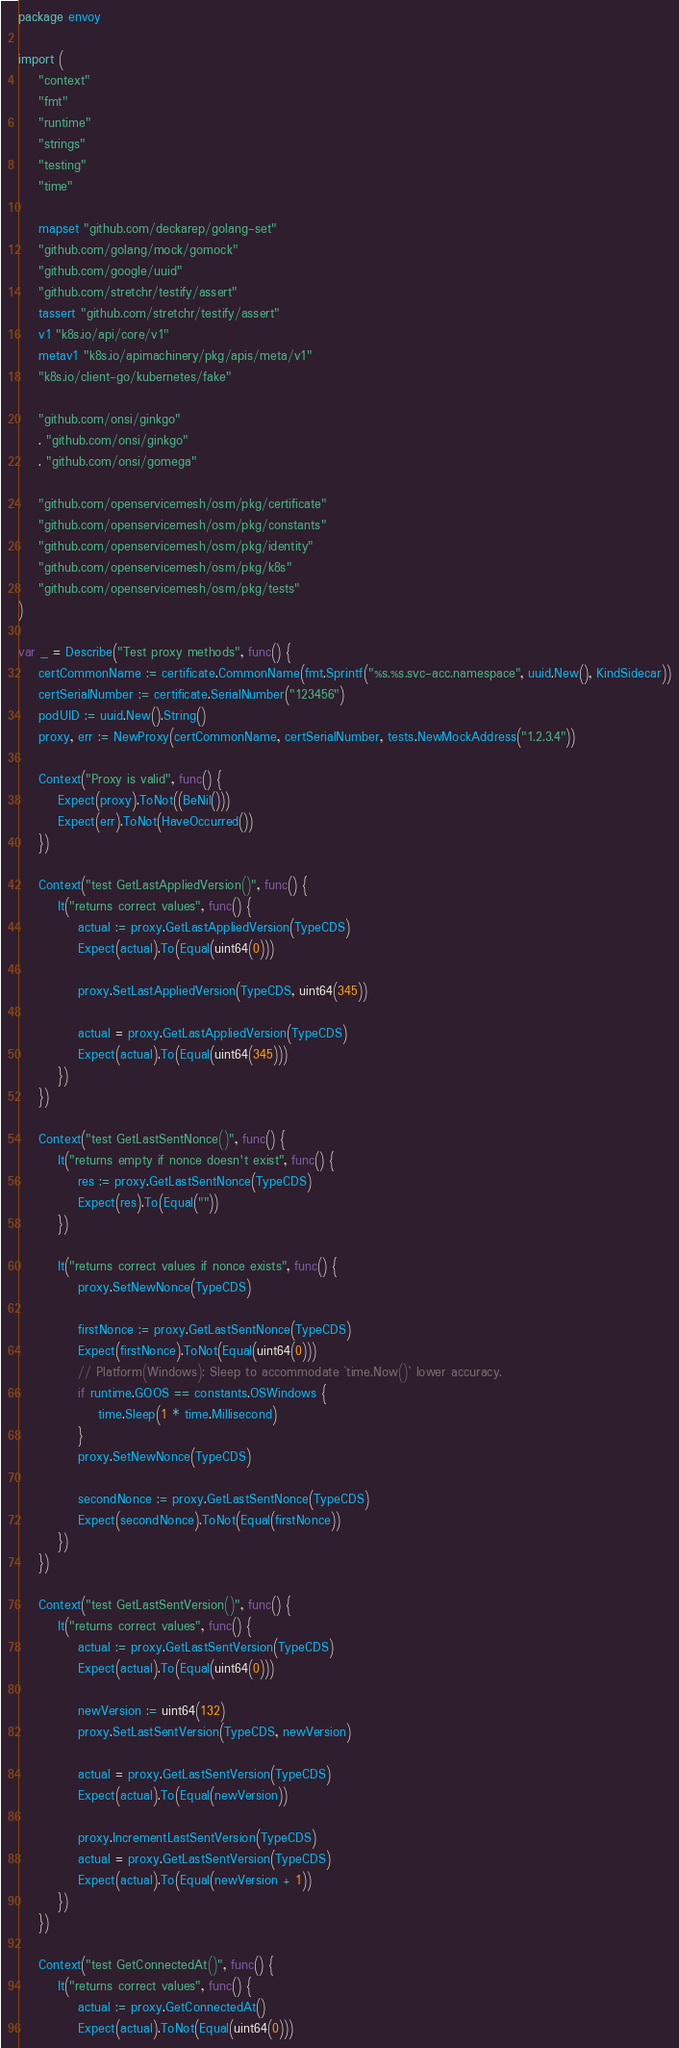Convert code to text. <code><loc_0><loc_0><loc_500><loc_500><_Go_>package envoy

import (
	"context"
	"fmt"
	"runtime"
	"strings"
	"testing"
	"time"

	mapset "github.com/deckarep/golang-set"
	"github.com/golang/mock/gomock"
	"github.com/google/uuid"
	"github.com/stretchr/testify/assert"
	tassert "github.com/stretchr/testify/assert"
	v1 "k8s.io/api/core/v1"
	metav1 "k8s.io/apimachinery/pkg/apis/meta/v1"
	"k8s.io/client-go/kubernetes/fake"

	"github.com/onsi/ginkgo"
	. "github.com/onsi/ginkgo"
	. "github.com/onsi/gomega"

	"github.com/openservicemesh/osm/pkg/certificate"
	"github.com/openservicemesh/osm/pkg/constants"
	"github.com/openservicemesh/osm/pkg/identity"
	"github.com/openservicemesh/osm/pkg/k8s"
	"github.com/openservicemesh/osm/pkg/tests"
)

var _ = Describe("Test proxy methods", func() {
	certCommonName := certificate.CommonName(fmt.Sprintf("%s.%s.svc-acc.namespace", uuid.New(), KindSidecar))
	certSerialNumber := certificate.SerialNumber("123456")
	podUID := uuid.New().String()
	proxy, err := NewProxy(certCommonName, certSerialNumber, tests.NewMockAddress("1.2.3.4"))

	Context("Proxy is valid", func() {
		Expect(proxy).ToNot((BeNil()))
		Expect(err).ToNot(HaveOccurred())
	})

	Context("test GetLastAppliedVersion()", func() {
		It("returns correct values", func() {
			actual := proxy.GetLastAppliedVersion(TypeCDS)
			Expect(actual).To(Equal(uint64(0)))

			proxy.SetLastAppliedVersion(TypeCDS, uint64(345))

			actual = proxy.GetLastAppliedVersion(TypeCDS)
			Expect(actual).To(Equal(uint64(345)))
		})
	})

	Context("test GetLastSentNonce()", func() {
		It("returns empty if nonce doesn't exist", func() {
			res := proxy.GetLastSentNonce(TypeCDS)
			Expect(res).To(Equal(""))
		})

		It("returns correct values if nonce exists", func() {
			proxy.SetNewNonce(TypeCDS)

			firstNonce := proxy.GetLastSentNonce(TypeCDS)
			Expect(firstNonce).ToNot(Equal(uint64(0)))
			// Platform(Windows): Sleep to accommodate `time.Now()` lower accuracy.
			if runtime.GOOS == constants.OSWindows {
				time.Sleep(1 * time.Millisecond)
			}
			proxy.SetNewNonce(TypeCDS)

			secondNonce := proxy.GetLastSentNonce(TypeCDS)
			Expect(secondNonce).ToNot(Equal(firstNonce))
		})
	})

	Context("test GetLastSentVersion()", func() {
		It("returns correct values", func() {
			actual := proxy.GetLastSentVersion(TypeCDS)
			Expect(actual).To(Equal(uint64(0)))

			newVersion := uint64(132)
			proxy.SetLastSentVersion(TypeCDS, newVersion)

			actual = proxy.GetLastSentVersion(TypeCDS)
			Expect(actual).To(Equal(newVersion))

			proxy.IncrementLastSentVersion(TypeCDS)
			actual = proxy.GetLastSentVersion(TypeCDS)
			Expect(actual).To(Equal(newVersion + 1))
		})
	})

	Context("test GetConnectedAt()", func() {
		It("returns correct values", func() {
			actual := proxy.GetConnectedAt()
			Expect(actual).ToNot(Equal(uint64(0)))</code> 